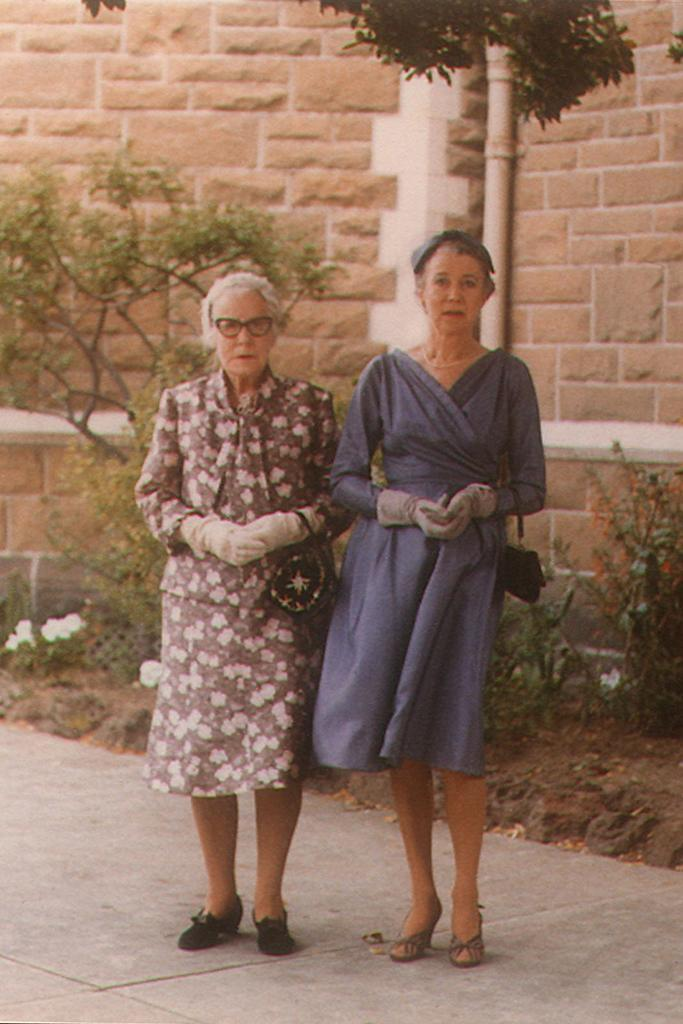How many people are in the image? There are two women in the image. What are the women doing in the image? The women are standing and holding bags. What can be seen in the background of the image? There is a brick wall and plants in the background of the image. What type of vegetable is being used as a pan in the image? There is no vegetable or pan present in the image. What religious symbols can be seen in the image? There are no religious symbols present in the image. 